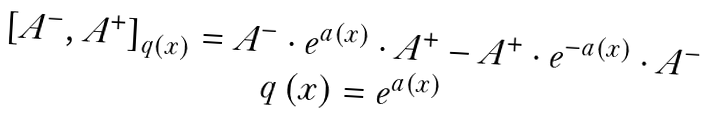Convert formula to latex. <formula><loc_0><loc_0><loc_500><loc_500>\begin{array} { c } \left [ A ^ { - } , A ^ { + } \right ] _ { q \left ( x \right ) } = A ^ { - } \cdot e ^ { a \left ( x \right ) } \cdot A ^ { + } - A ^ { + } \cdot e ^ { - a \left ( x \right ) } \cdot A ^ { - } \\ q \left ( x \right ) = e ^ { a \left ( x \right ) } \end{array}</formula> 